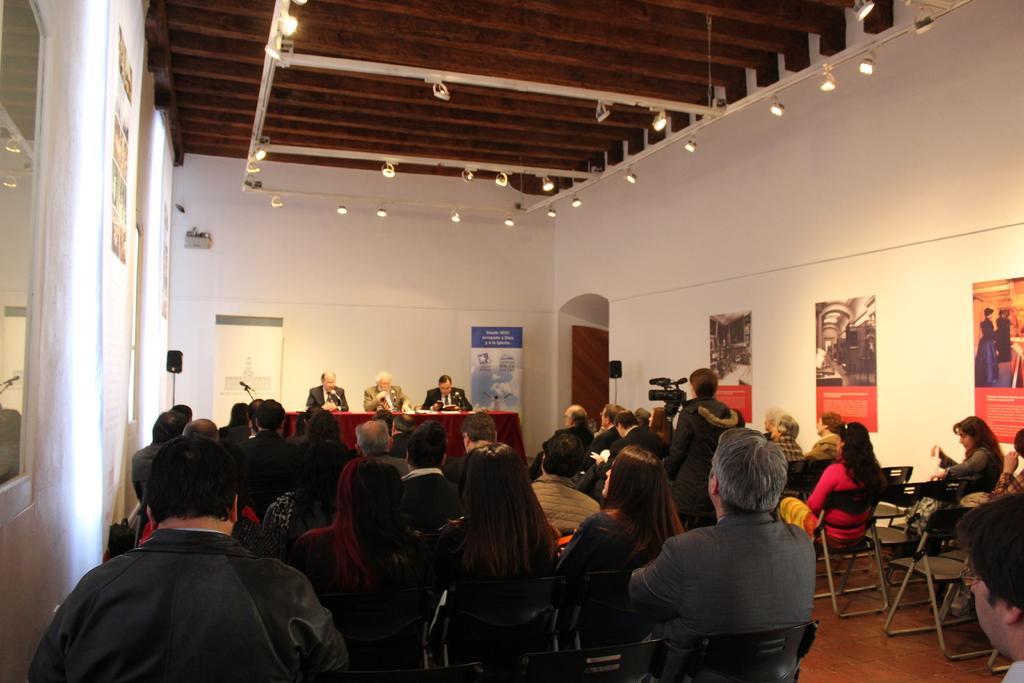In one or two sentences, can you explain what this image depicts? In this image I can see some people are sitting on the chairs. At the top I can see the lights. 